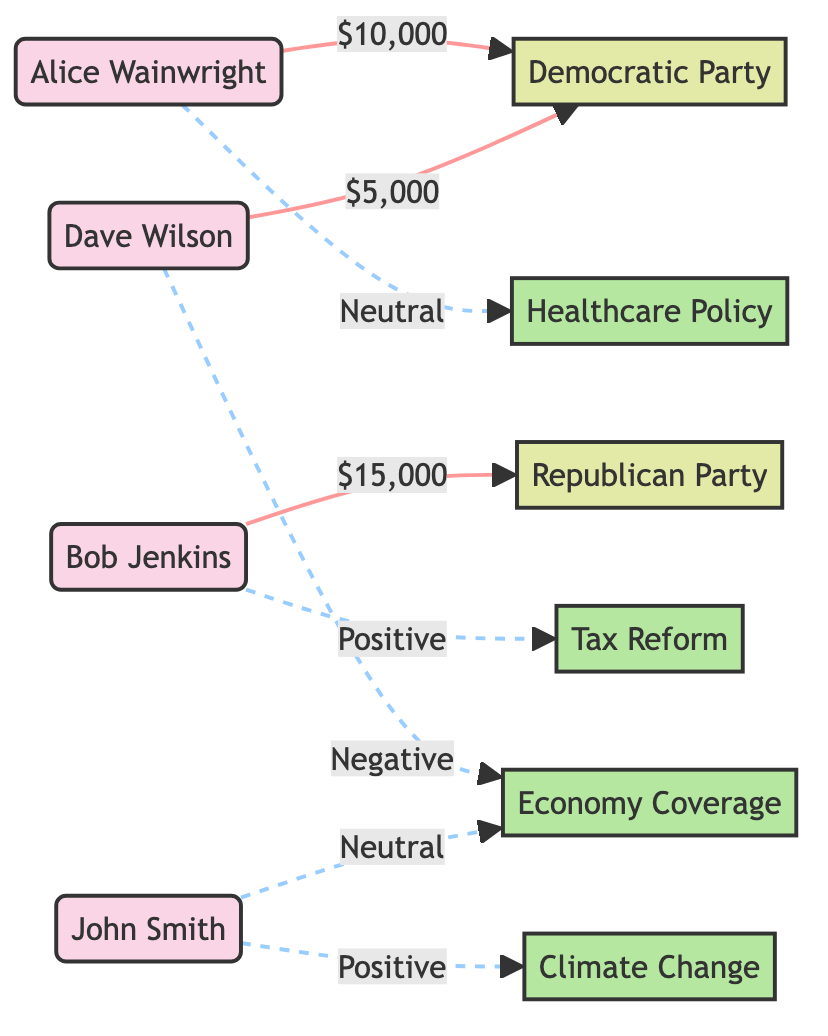What is the total number of Executives in the diagram? The diagram lists four Executives: Alice Wainwright, Bob Jenkins, Dave Wilson, and John Smith. By simply counting the nodes with the type "Executive," we find a total of four.
Answer: 4 Which Executive donated to the Republican Party? According to the edges, Bob Jenkins is the only Executive that has a direct connection to the Republican Party with a donation of $15,000. This can be identified by following the edge from Bob Jenkins to the Republican Party node.
Answer: Bob Jenkins How much did Alice Wainwright donate? The diagram shows that Alice Wainwright donated $10,000 to the Democratic Party. This information is found on the edge connecting her node to the Democratic Party node.
Answer: $10,000 What type of coverage is associated with John Smith's reporting on Climate Change? The diagram indicates that John Smith provides Positive Coverage for Climate Change. This can be determined by the edge that connects John Smith to the Climate Change node with the label "Positive Coverage."
Answer: Positive Coverage Which news segment received Negative Coverage and who is associated with it? The Economy Coverage segment received Negative Coverage, as shown by the edge linking Dave Wilson to the Economy Coverage node, indicating a negative association. Therefore, Dave Wilson is the Executive linked to this negative coverage.
Answer: Economy Coverage, Dave Wilson How many total donations from all Executives to different political parties can be seen? Adding the donations shown in the edges, we have $10,000 from Alice Wainwright to the Democratic Party, $15,000 from Bob Jenkins to the Republican Party, and $5,000 from Dave Wilson to the Democratic Party, giving us a total of $30,000. This is calculated as follows: $10,000 + $15,000 + $5,000 = $30,000.
Answer: $30,000 What is the relationship between Bob Jenkins and Tax Reform? The diagram shows that Bob Jenkins has a Positive Coverage relationship with the Tax Reform news segment. This is reflected on the edge that connects Bob Jenkins to the Tax Reform node with the label "Positive Coverage."
Answer: Positive Coverage How many Nodes are categorized as News Segments in the diagram? The diagram contains four News Segments: Climate Change, Tax Reform, Healthcare Policy, and Economy Coverage. By counting these nodes, we can ascertain that there are four News Segments in total.
Answer: 4 